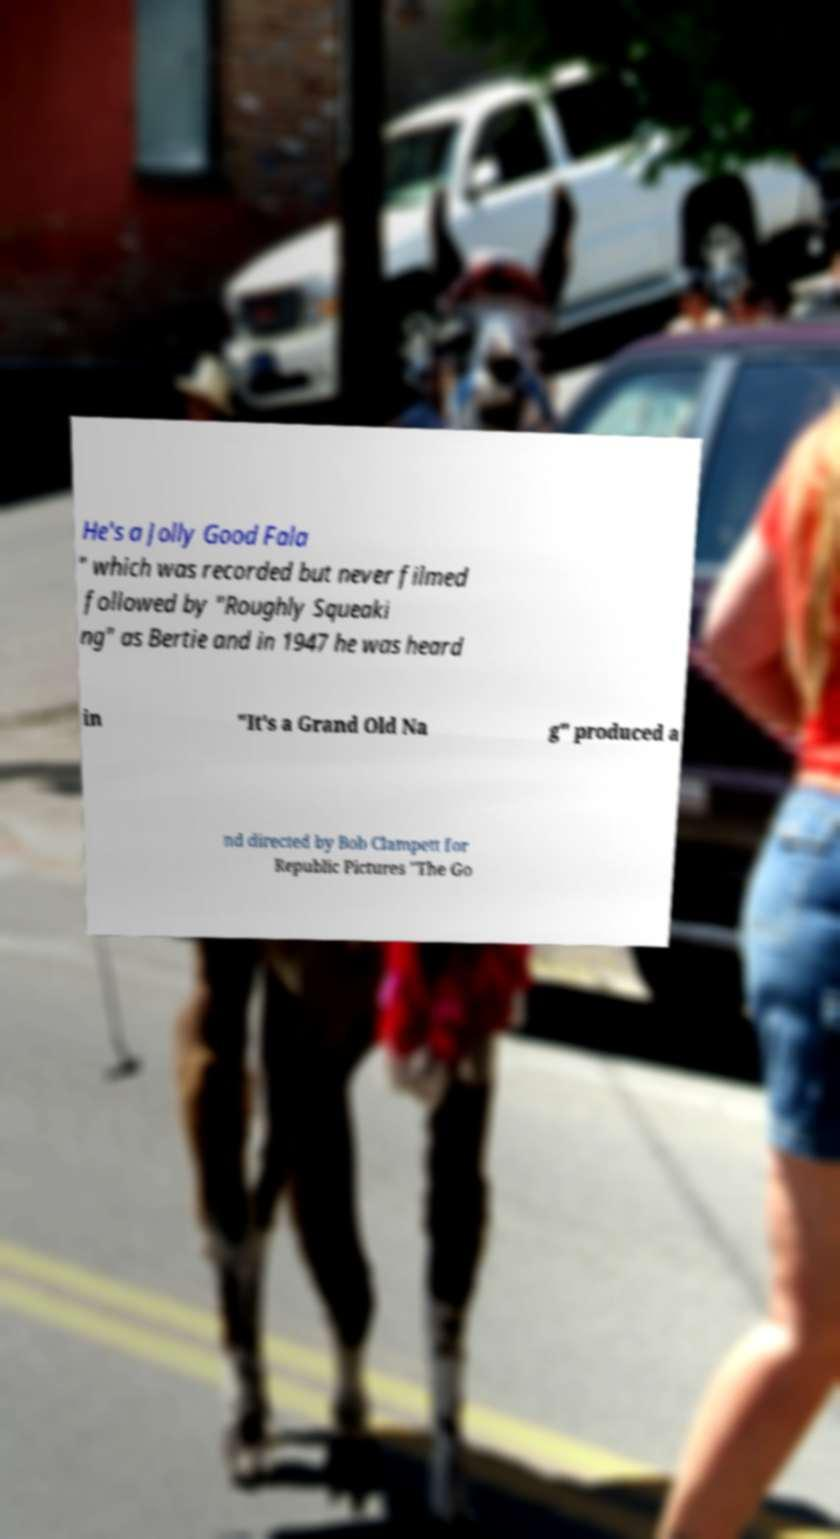Can you accurately transcribe the text from the provided image for me? He's a Jolly Good Fala " which was recorded but never filmed followed by "Roughly Squeaki ng" as Bertie and in 1947 he was heard in "It's a Grand Old Na g" produced a nd directed by Bob Clampett for Republic Pictures "The Go 